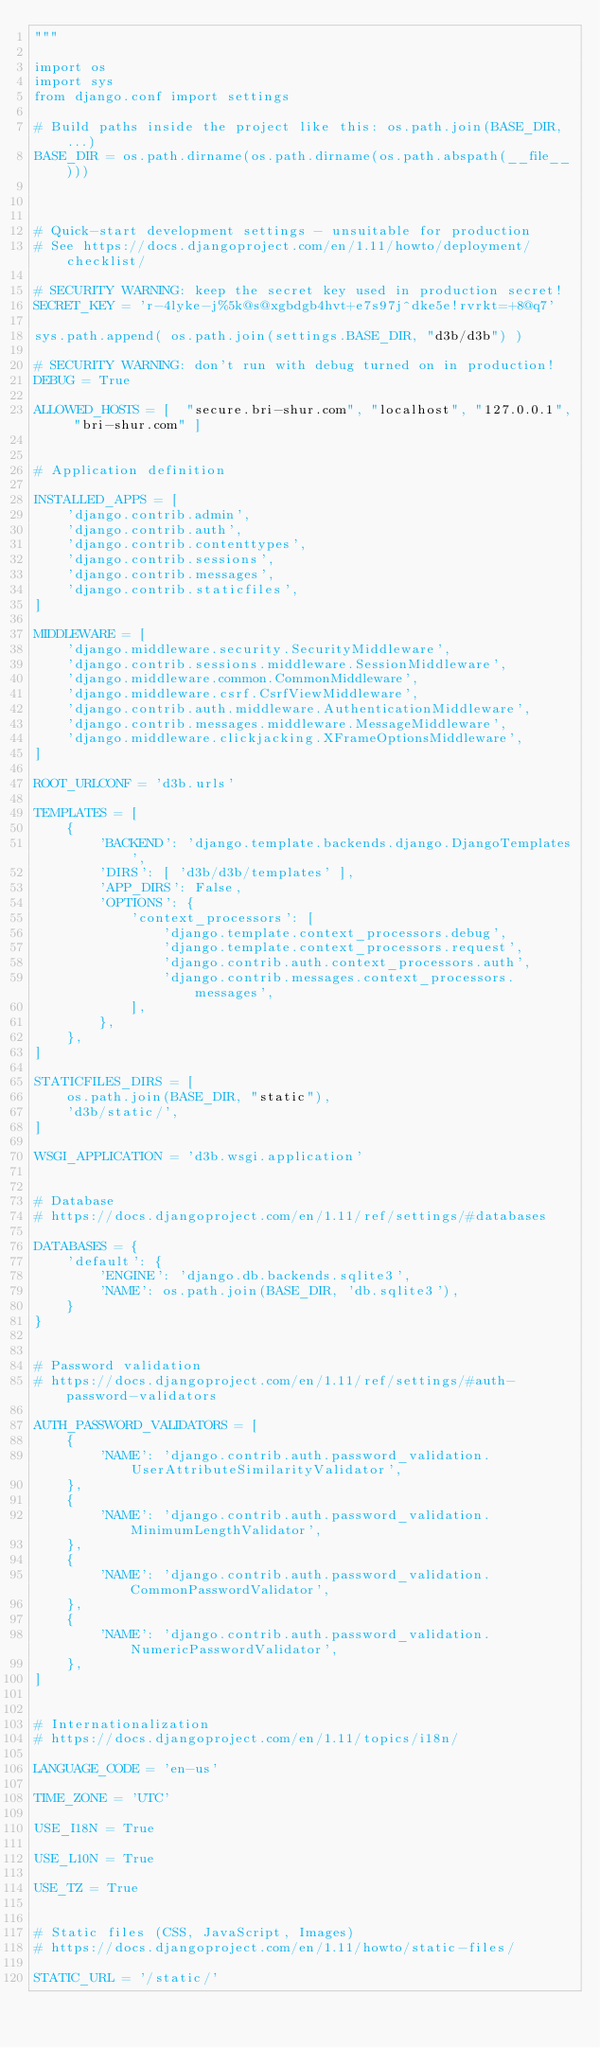Convert code to text. <code><loc_0><loc_0><loc_500><loc_500><_Python_>"""

import os
import sys
from django.conf import settings

# Build paths inside the project like this: os.path.join(BASE_DIR, ...)
BASE_DIR = os.path.dirname(os.path.dirname(os.path.abspath(__file__)))



# Quick-start development settings - unsuitable for production
# See https://docs.djangoproject.com/en/1.11/howto/deployment/checklist/

# SECURITY WARNING: keep the secret key used in production secret!
SECRET_KEY = 'r-4lyke-j%5k@s@xgbdgb4hvt+e7s97j^dke5e!rvrkt=+8@q7'

sys.path.append( os.path.join(settings.BASE_DIR, "d3b/d3b") )

# SECURITY WARNING: don't run with debug turned on in production!
DEBUG = True

ALLOWED_HOSTS = [  "secure.bri-shur.com", "localhost", "127.0.0.1", "bri-shur.com" ]


# Application definition

INSTALLED_APPS = [
    'django.contrib.admin',
    'django.contrib.auth',
    'django.contrib.contenttypes',
    'django.contrib.sessions',
    'django.contrib.messages',
    'django.contrib.staticfiles',
]

MIDDLEWARE = [
    'django.middleware.security.SecurityMiddleware',
    'django.contrib.sessions.middleware.SessionMiddleware',
    'django.middleware.common.CommonMiddleware',
    'django.middleware.csrf.CsrfViewMiddleware',
    'django.contrib.auth.middleware.AuthenticationMiddleware',
    'django.contrib.messages.middleware.MessageMiddleware',
    'django.middleware.clickjacking.XFrameOptionsMiddleware',
]

ROOT_URLCONF = 'd3b.urls'

TEMPLATES = [
    {
        'BACKEND': 'django.template.backends.django.DjangoTemplates',
        'DIRS': [ 'd3b/d3b/templates' ],
        'APP_DIRS': False,
        'OPTIONS': {
            'context_processors': [
                'django.template.context_processors.debug',
                'django.template.context_processors.request',
                'django.contrib.auth.context_processors.auth',
                'django.contrib.messages.context_processors.messages',
            ],
        },
    },
]

STATICFILES_DIRS = [
    os.path.join(BASE_DIR, "static"),
    'd3b/static/',
]

WSGI_APPLICATION = 'd3b.wsgi.application'


# Database
# https://docs.djangoproject.com/en/1.11/ref/settings/#databases

DATABASES = {
    'default': {
        'ENGINE': 'django.db.backends.sqlite3',
        'NAME': os.path.join(BASE_DIR, 'db.sqlite3'),
    }
}


# Password validation
# https://docs.djangoproject.com/en/1.11/ref/settings/#auth-password-validators

AUTH_PASSWORD_VALIDATORS = [
    {
        'NAME': 'django.contrib.auth.password_validation.UserAttributeSimilarityValidator',
    },
    {
        'NAME': 'django.contrib.auth.password_validation.MinimumLengthValidator',
    },
    {
        'NAME': 'django.contrib.auth.password_validation.CommonPasswordValidator',
    },
    {
        'NAME': 'django.contrib.auth.password_validation.NumericPasswordValidator',
    },
]


# Internationalization
# https://docs.djangoproject.com/en/1.11/topics/i18n/

LANGUAGE_CODE = 'en-us'

TIME_ZONE = 'UTC'

USE_I18N = True

USE_L10N = True

USE_TZ = True


# Static files (CSS, JavaScript, Images)
# https://docs.djangoproject.com/en/1.11/howto/static-files/

STATIC_URL = '/static/'
</code> 